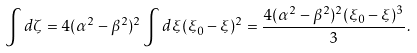Convert formula to latex. <formula><loc_0><loc_0><loc_500><loc_500>\int d \zeta = 4 ( \alpha ^ { 2 } - \beta ^ { 2 } ) ^ { 2 } \int d \xi ( \xi _ { 0 } - \xi ) ^ { 2 } = \frac { 4 ( \alpha ^ { 2 } - \beta ^ { 2 } ) ^ { 2 } ( \xi _ { 0 } - \xi ) ^ { 3 } } { 3 } .</formula> 